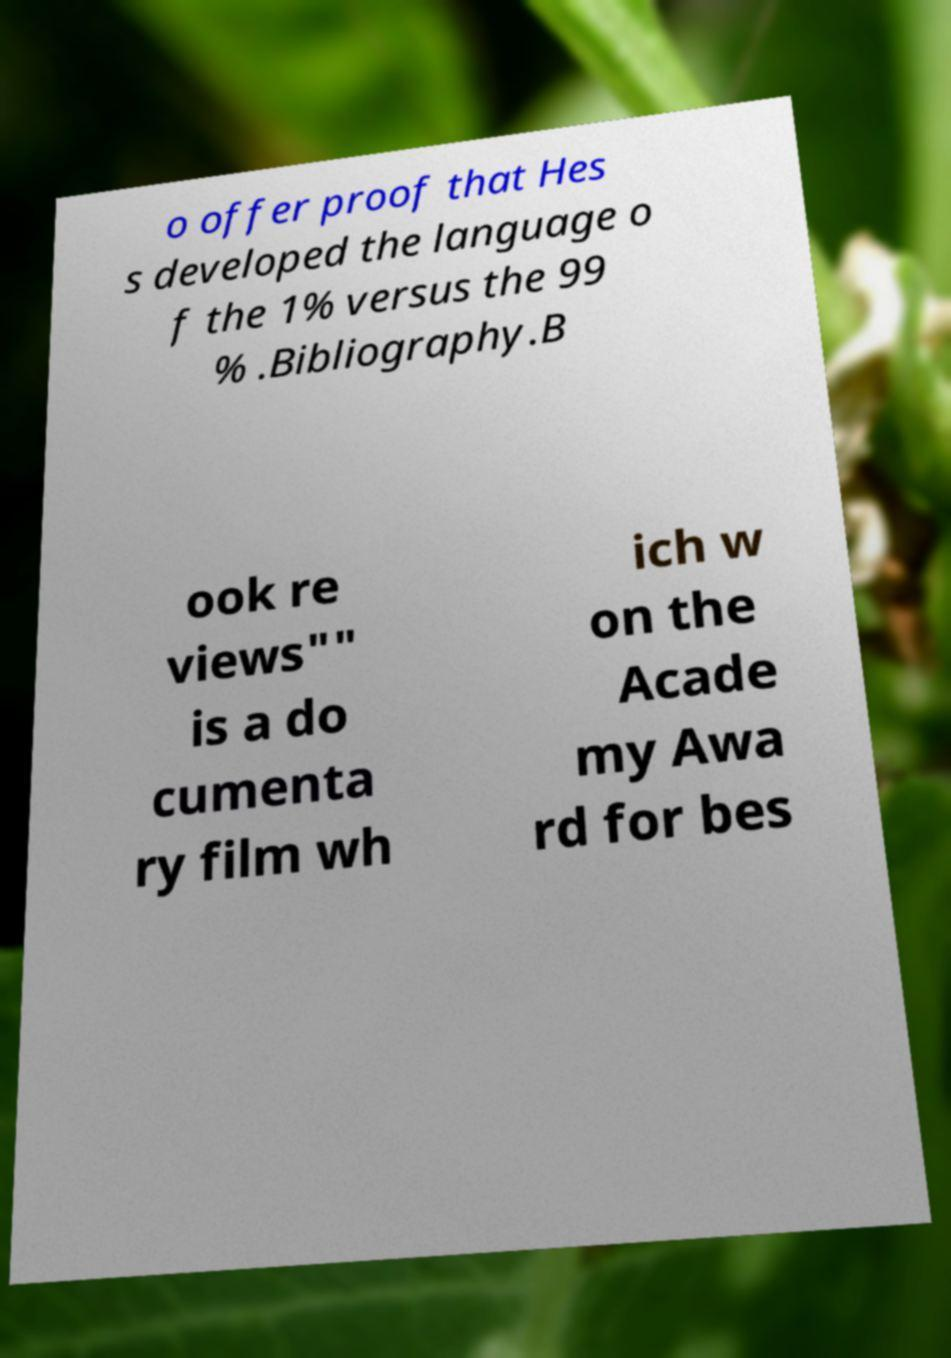For documentation purposes, I need the text within this image transcribed. Could you provide that? o offer proof that Hes s developed the language o f the 1% versus the 99 % .Bibliography.B ook re views"" is a do cumenta ry film wh ich w on the Acade my Awa rd for bes 